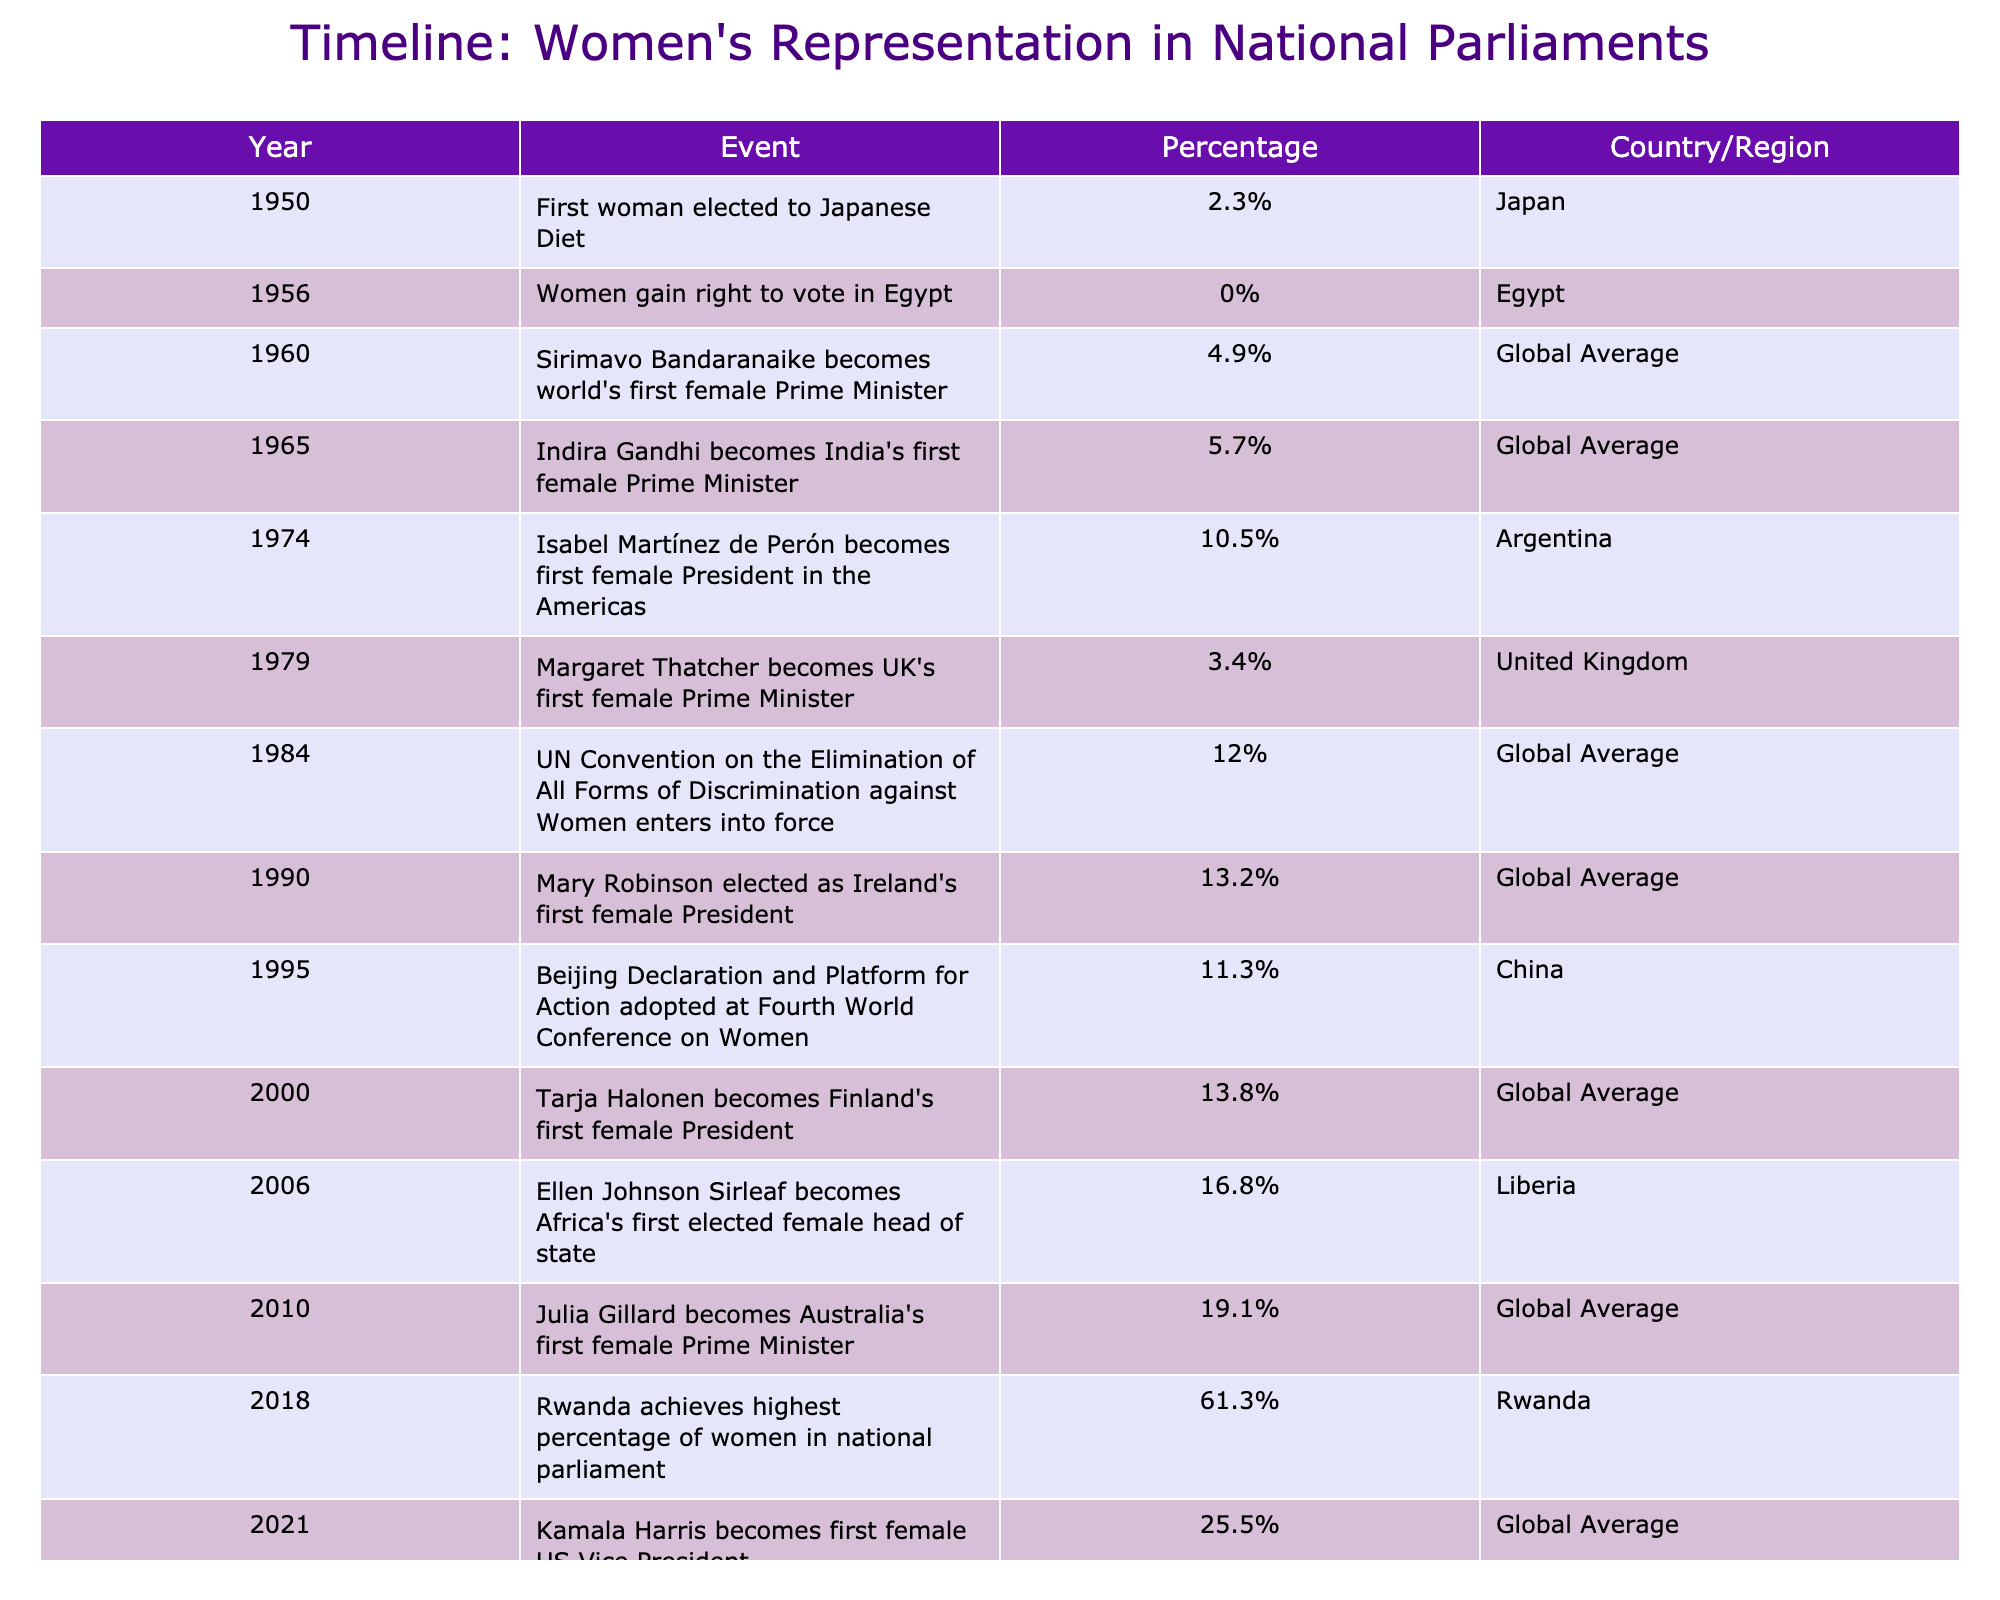What year did Rwanda achieve the highest percentage of women in national parliament? From the table, we can see that the year associated with Rwanda achieving the highest percentage of women in national parliament is 2018.
Answer: 2018 What percentage of women representatives was noted when the UN Convention entered into force in 1984? The table indicates that in 1984, the percentage of women representatives at a global average was 12%.
Answer: 12% Was Ellen Johnson Sirleaf the first woman elected as a head of state in Africa? According to the table, Ellen Johnson Sirleaf became Africa's first elected female head of state in 2006, which confirms that she was indeed the first.
Answer: Yes What is the difference in women's representation percentage between 2010 and 2021? From the table, the percentage for women in 2010 was 19.1%, and for 2021, it was 25.5%. The difference is calculated as 25.5 - 19.1 = 6.4%.
Answer: 6.4% Which country had the lowest representation of women in parliament in 1950? The table shows that in 1950, Japan had a 2.3% representation of women in the Diet, which is the lowest percentage listed in that year.
Answer: Japan How many years passed between the election of the first female Prime Minister and the first female President noted in the table? The first female Prime Minister was Sirimavo Bandaranaike in 1960 and the first female President in the Americas was Isabel Martínez de Perón in 1974. The time between these events is 1974 - 1960 = 14 years.
Answer: 14 years What was the global average percentage of women in national parliaments in 1995? The table indicates that in 1995, the Beijing Declaration and Platform for Action was adopted, and the percentage of women representatives was 11.3% in China.
Answer: 11.3% Which country had a woman become President first, according to this timeline? The first woman noted to become a President was Isabel Martínez de Perón in Argentina in 1974, according to the table.
Answer: Argentina 